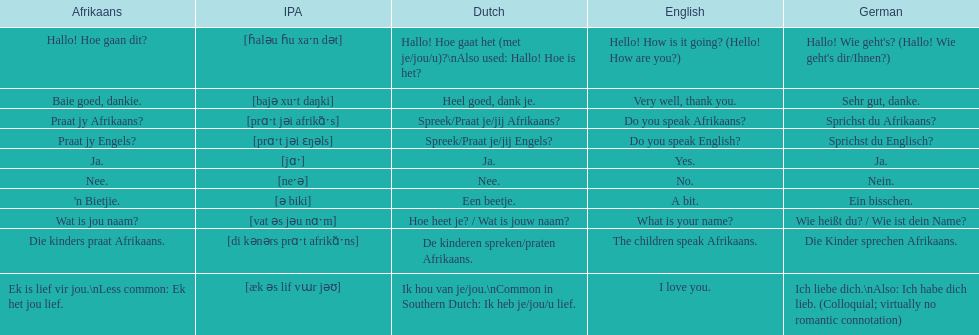How do you say 'do you speak afrikaans?' in afrikaans? Praat jy Afrikaans?. 